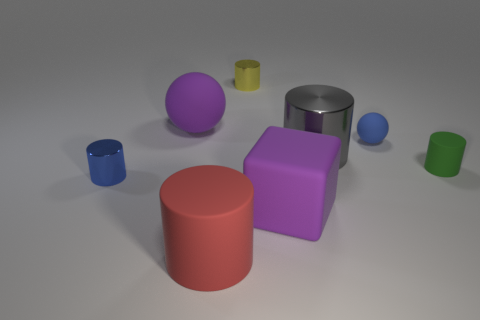Is there a block that has the same material as the small green cylinder?
Your answer should be very brief. Yes. Is the color of the rubber cube the same as the large sphere?
Your answer should be compact. Yes. There is a tiny object that is both left of the cube and in front of the large purple matte ball; what material is it?
Offer a very short reply. Metal. What is the color of the large rubber sphere?
Your answer should be very brief. Purple. What number of other tiny blue objects are the same shape as the blue metal object?
Ensure brevity in your answer.  0. Are the big cylinder that is left of the big gray object and the large cylinder that is behind the tiny green cylinder made of the same material?
Your answer should be very brief. No. There is a purple thing in front of the purple object that is behind the tiny green cylinder; what is its size?
Keep it short and to the point. Large. There is a tiny blue thing that is the same shape as the tiny green object; what is it made of?
Your response must be concise. Metal. There is a purple matte thing that is behind the green cylinder; does it have the same shape as the small blue object that is behind the small blue cylinder?
Your answer should be compact. Yes. Is the number of cylinders greater than the number of objects?
Provide a succinct answer. No. 